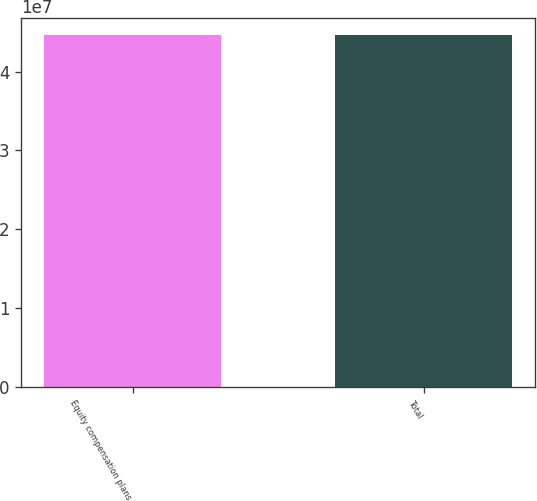Convert chart to OTSL. <chart><loc_0><loc_0><loc_500><loc_500><bar_chart><fcel>Equity compensation plans<fcel>Total<nl><fcel>4.45898e+07<fcel>4.45898e+07<nl></chart> 